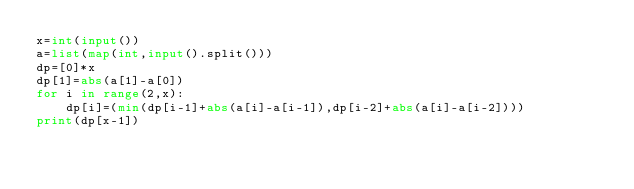Convert code to text. <code><loc_0><loc_0><loc_500><loc_500><_Python_>x=int(input())
a=list(map(int,input().split()))
dp=[0]*x
dp[1]=abs(a[1]-a[0])
for i in range(2,x):
    dp[i]=(min(dp[i-1]+abs(a[i]-a[i-1]),dp[i-2]+abs(a[i]-a[i-2])))
print(dp[x-1])    </code> 